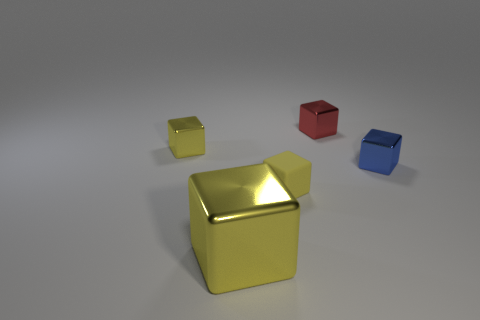Subtract all yellow cubes. How many were subtracted if there are1yellow cubes left? 2 Subtract all purple cylinders. How many yellow blocks are left? 3 Subtract all red blocks. How many blocks are left? 4 Subtract all blue cubes. How many cubes are left? 4 Subtract all gray blocks. Subtract all green spheres. How many blocks are left? 5 Add 2 small matte cylinders. How many objects exist? 7 Subtract 0 red balls. How many objects are left? 5 Subtract all tiny blue metallic blocks. Subtract all small blue objects. How many objects are left? 3 Add 2 yellow things. How many yellow things are left? 5 Add 2 big yellow shiny things. How many big yellow shiny things exist? 3 